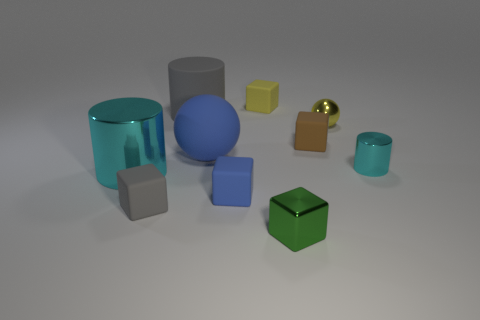Subtract 2 blocks. How many blocks are left? 3 Subtract all brown blocks. How many blocks are left? 4 Subtract all blue matte cubes. How many cubes are left? 4 Subtract all purple cubes. Subtract all purple cylinders. How many cubes are left? 5 Subtract all spheres. How many objects are left? 8 Subtract all small cylinders. Subtract all cylinders. How many objects are left? 6 Add 5 blue balls. How many blue balls are left? 6 Add 5 yellow shiny blocks. How many yellow shiny blocks exist? 5 Subtract 0 cyan blocks. How many objects are left? 10 